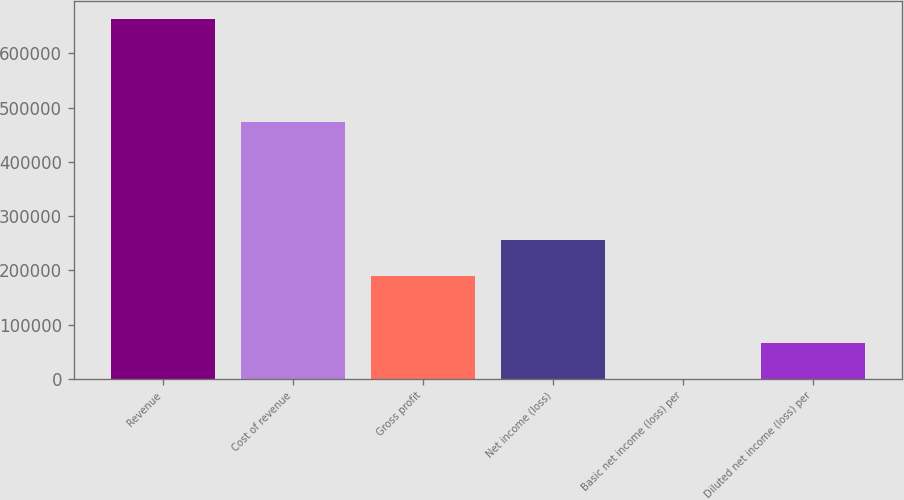<chart> <loc_0><loc_0><loc_500><loc_500><bar_chart><fcel>Revenue<fcel>Cost of revenue<fcel>Gross profit<fcel>Net income (loss)<fcel>Basic net income (loss) per<fcel>Diluted net income (loss) per<nl><fcel>664231<fcel>474535<fcel>189696<fcel>256119<fcel>0.37<fcel>66423.4<nl></chart> 